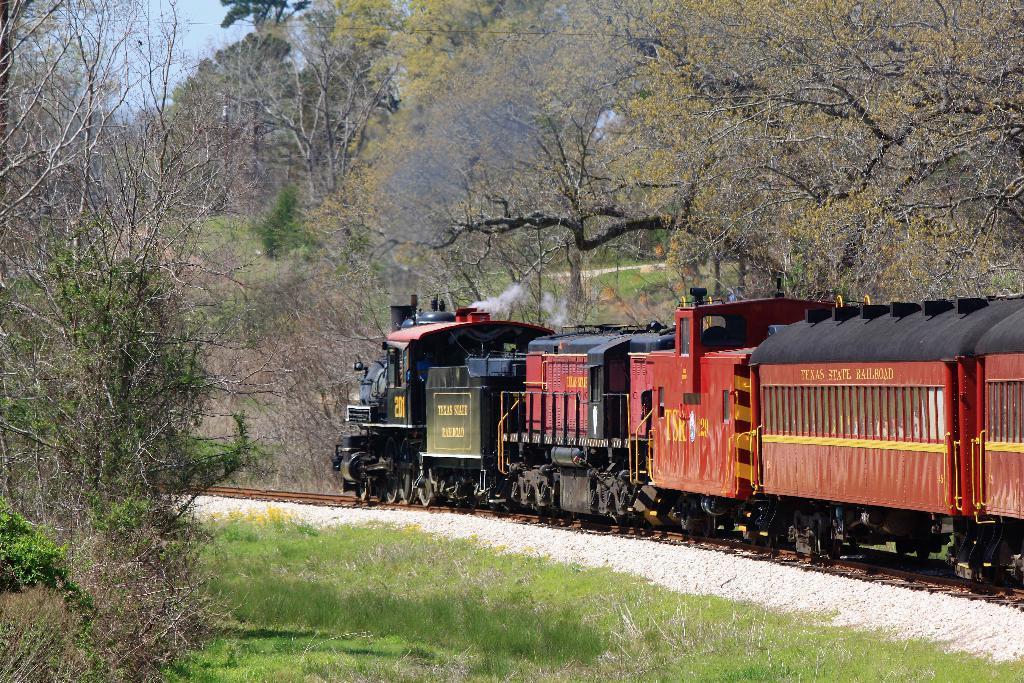Could you give a brief overview of what you see in this image? In this picture we can see a train on the track. Here we can see grass and plants. In the background there are trees and sky. 